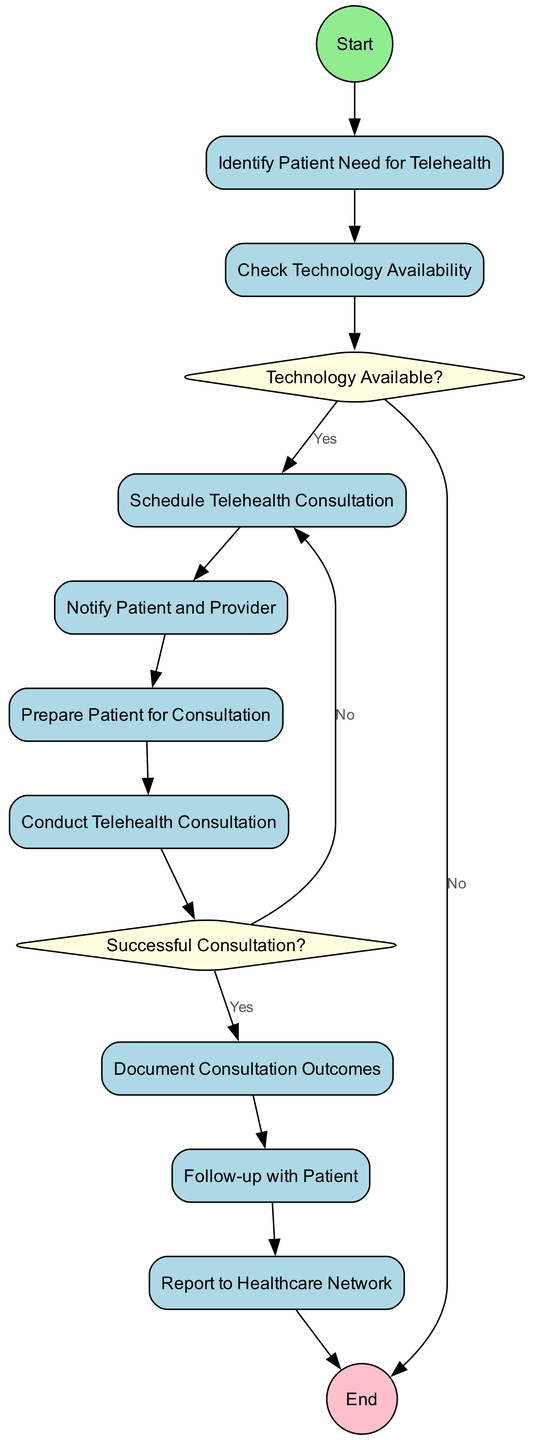What is the first action node in the diagram? The first action node is identified by the flow starting from "Start". It leads directly to "Identify Patient Need for Telehealth".
Answer: Identify Patient Need for Telehealth How many action nodes are there in total? By counting the action nodes listed in the diagram, there are a total of eight action nodes.
Answer: 8 What decision node checks the technology availability? The diagram indicates that the decision node checking the technology is labeled "Technology Available?".
Answer: Technology Available? What happens if the technology is unavailable? Following the decision node "Technology Available?", if the result is "No", the flow progresses to the "End" node without further actions.
Answer: End What follows "Conduct Telehealth Consultation"? After "Conduct Telehealth Consultation", the next step in the diagram is "Successful Consultation?".
Answer: Successful Consultation? What is the outcome if the consultation is unsuccessful? If the consultation is deemed unsuccessful, as per the diagram, the flow redirects back to "Schedule Telehealth Consultation".
Answer: Schedule Telehealth Consultation How many nodes connect directly to "Notify Patient and Provider"? The only node that connects directly to "Notify Patient and Provider" is "Schedule Telehealth Consultation", indicating there is one incoming edge.
Answer: 1 What is the last action in the sequence of the diagram? The last action before concluding the flow is "Report to Healthcare Network", directly followed by the "End" node.
Answer: Report to Healthcare Network What is the relationship between "Follow-up with Patient" and "Document Consultation Outcomes"? The flow indicates that "Document Consultation Outcomes" follows directly after "Follow-up with Patient", creating a sequential relationship.
Answer: Document Consultation Outcomes 